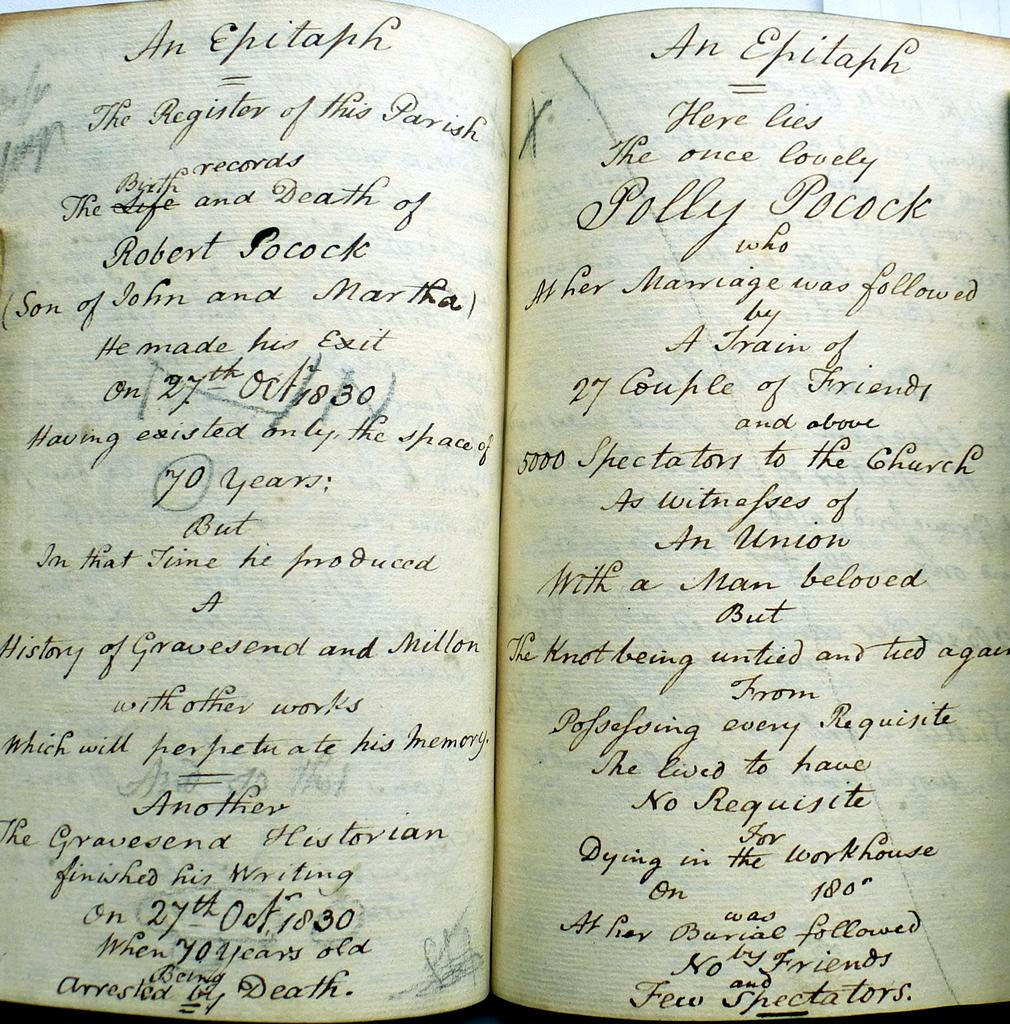<image>
Summarize the visual content of the image. A very old looking book open to some pages that read An Epitaph at the top. 